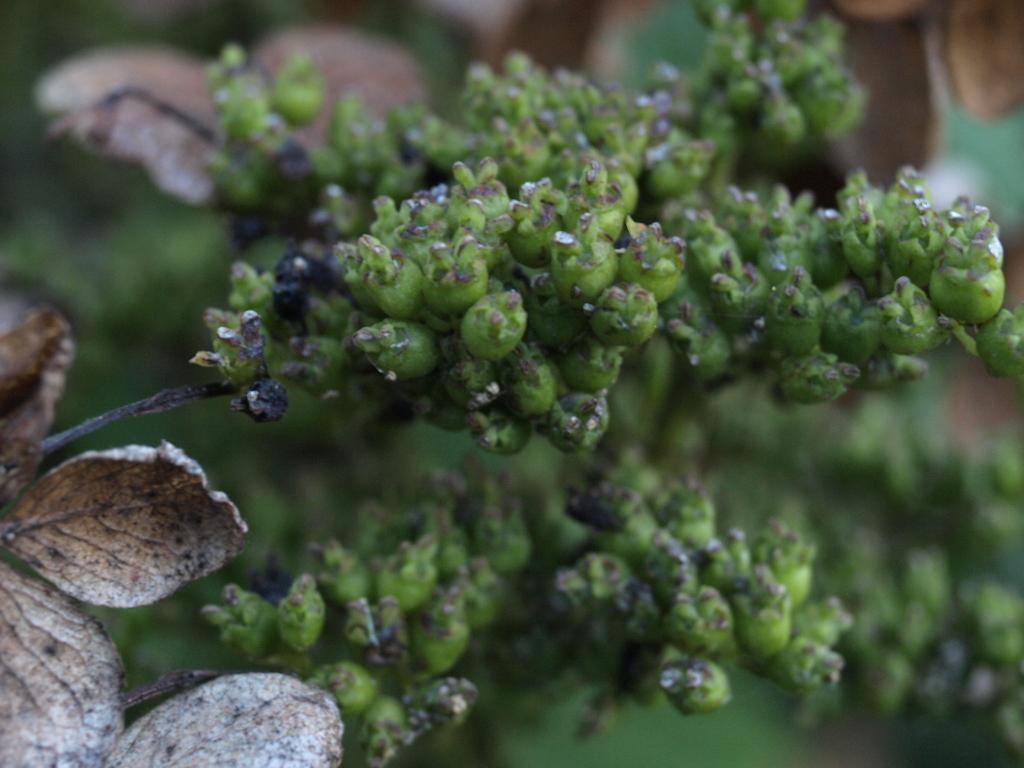What type of living organisms can be seen in the image? Plants can be seen in the image. What can be found on the left side of the image? There are dried leaves on the left side of the image. What color is the background of the image? The background of the image is green in color. How is the background of the image depicted? The background is blurred. What type of behavior does the dad exhibit in the image? There is no dad present in the image, so it is not possible to comment on his behavior. 